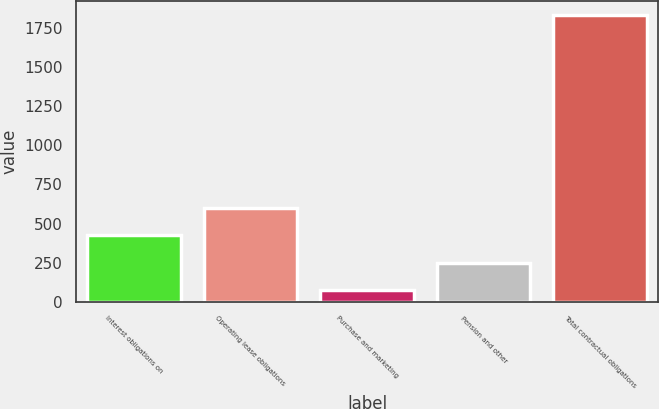Convert chart to OTSL. <chart><loc_0><loc_0><loc_500><loc_500><bar_chart><fcel>Interest obligations on<fcel>Operating lease obligations<fcel>Purchase and marketing<fcel>Pension and other<fcel>Total contractual obligations<nl><fcel>426.68<fcel>601.77<fcel>76.5<fcel>251.59<fcel>1827.4<nl></chart> 